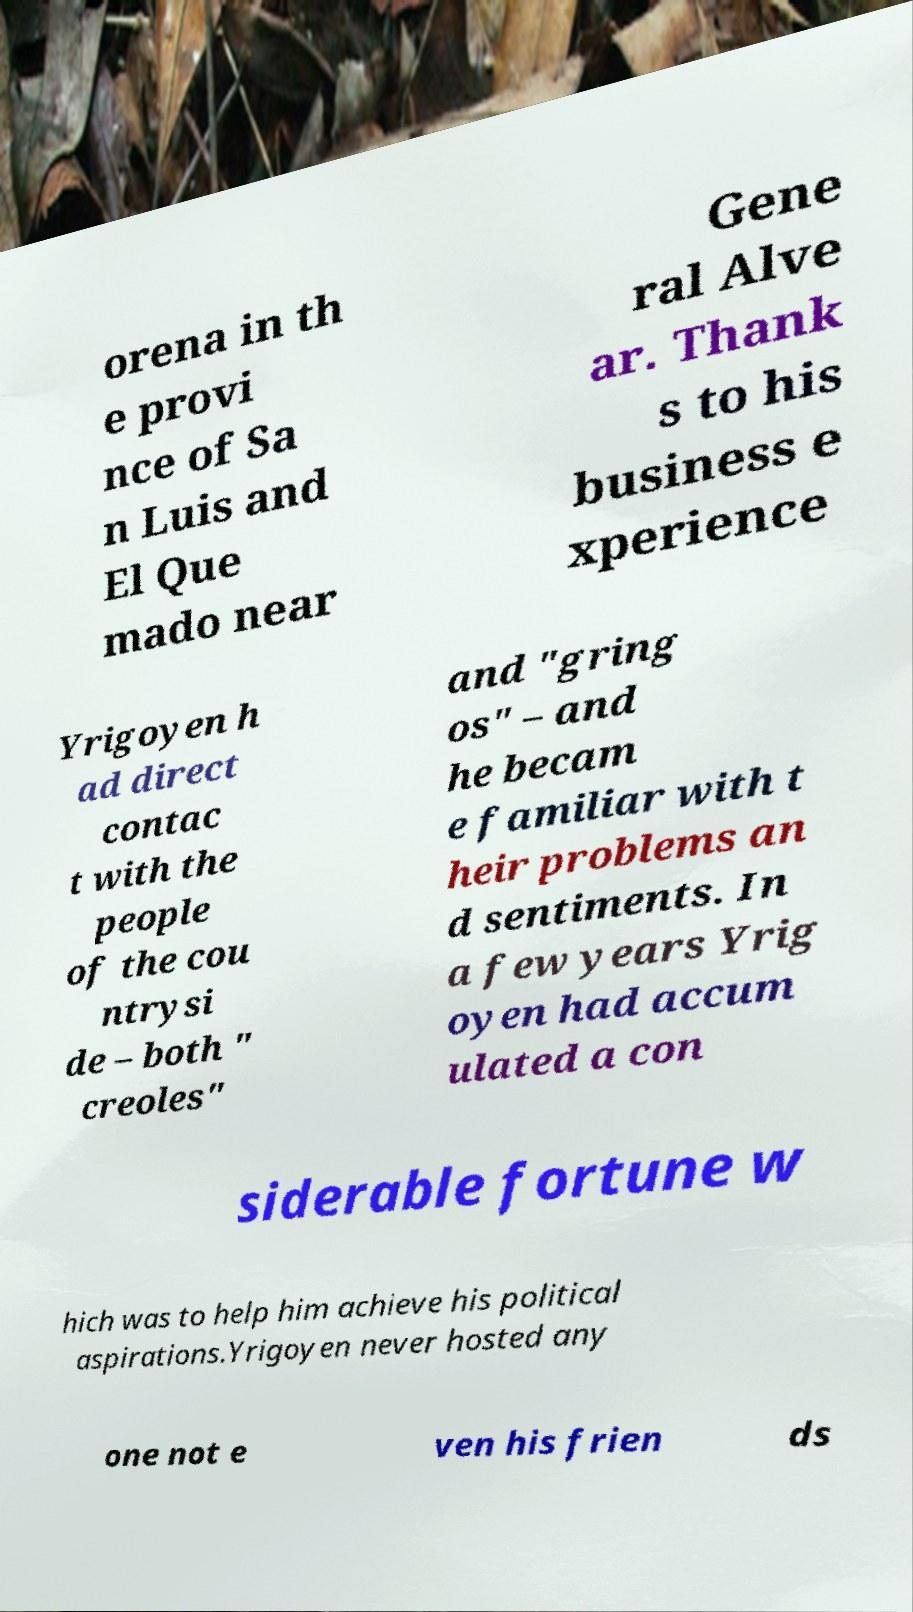I need the written content from this picture converted into text. Can you do that? orena in th e provi nce of Sa n Luis and El Que mado near Gene ral Alve ar. Thank s to his business e xperience Yrigoyen h ad direct contac t with the people of the cou ntrysi de – both " creoles" and "gring os" – and he becam e familiar with t heir problems an d sentiments. In a few years Yrig oyen had accum ulated a con siderable fortune w hich was to help him achieve his political aspirations.Yrigoyen never hosted any one not e ven his frien ds 